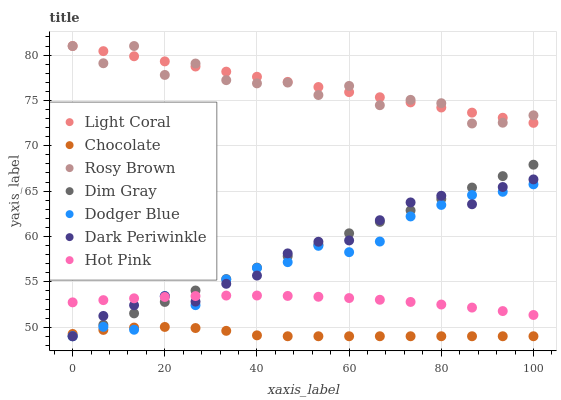Does Chocolate have the minimum area under the curve?
Answer yes or no. Yes. Does Light Coral have the maximum area under the curve?
Answer yes or no. Yes. Does Rosy Brown have the minimum area under the curve?
Answer yes or no. No. Does Rosy Brown have the maximum area under the curve?
Answer yes or no. No. Is Light Coral the smoothest?
Answer yes or no. Yes. Is Rosy Brown the roughest?
Answer yes or no. Yes. Is Chocolate the smoothest?
Answer yes or no. No. Is Chocolate the roughest?
Answer yes or no. No. Does Dim Gray have the lowest value?
Answer yes or no. Yes. Does Rosy Brown have the lowest value?
Answer yes or no. No. Does Light Coral have the highest value?
Answer yes or no. Yes. Does Chocolate have the highest value?
Answer yes or no. No. Is Hot Pink less than Light Coral?
Answer yes or no. Yes. Is Light Coral greater than Dark Periwinkle?
Answer yes or no. Yes. Does Dark Periwinkle intersect Hot Pink?
Answer yes or no. Yes. Is Dark Periwinkle less than Hot Pink?
Answer yes or no. No. Is Dark Periwinkle greater than Hot Pink?
Answer yes or no. No. Does Hot Pink intersect Light Coral?
Answer yes or no. No. 